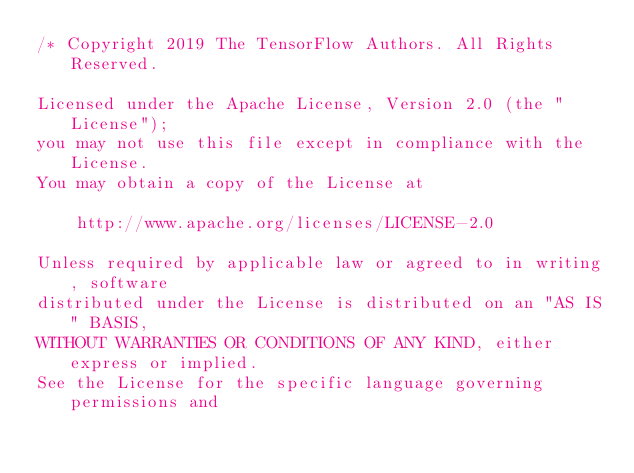Convert code to text. <code><loc_0><loc_0><loc_500><loc_500><_ObjectiveC_>/* Copyright 2019 The TensorFlow Authors. All Rights Reserved.

Licensed under the Apache License, Version 2.0 (the "License");
you may not use this file except in compliance with the License.
You may obtain a copy of the License at

    http://www.apache.org/licenses/LICENSE-2.0

Unless required by applicable law or agreed to in writing, software
distributed under the License is distributed on an "AS IS" BASIS,
WITHOUT WARRANTIES OR CONDITIONS OF ANY KIND, either express or implied.
See the License for the specific language governing permissions and</code> 